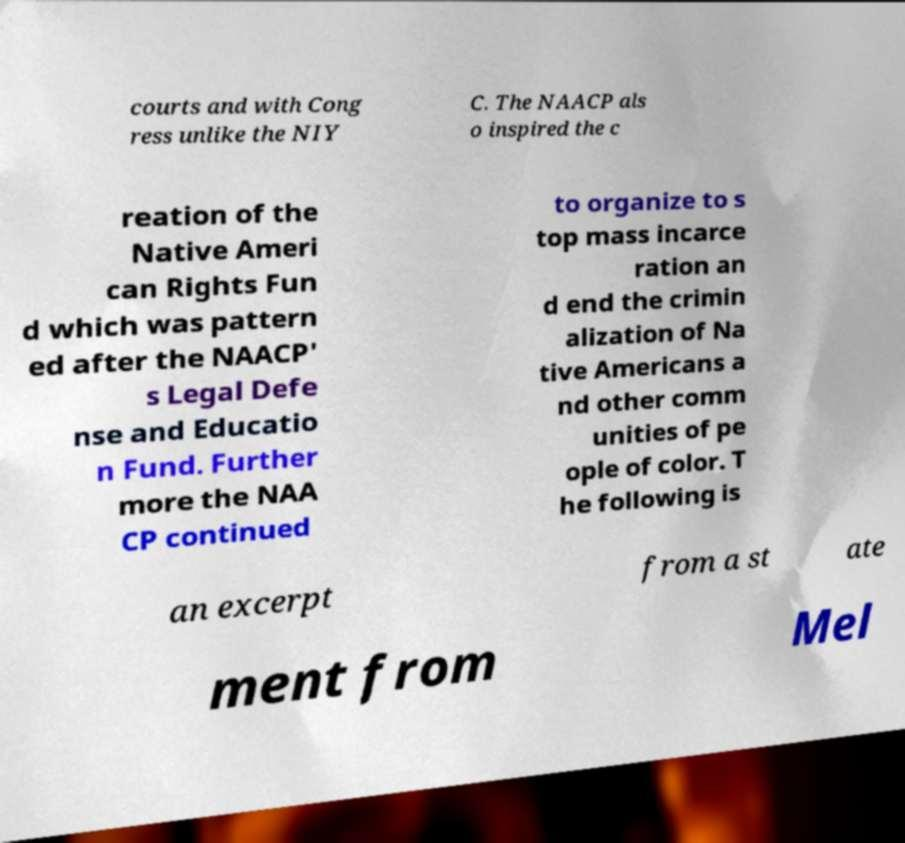Please read and relay the text visible in this image. What does it say? courts and with Cong ress unlike the NIY C. The NAACP als o inspired the c reation of the Native Ameri can Rights Fun d which was pattern ed after the NAACP' s Legal Defe nse and Educatio n Fund. Further more the NAA CP continued to organize to s top mass incarce ration an d end the crimin alization of Na tive Americans a nd other comm unities of pe ople of color. T he following is an excerpt from a st ate ment from Mel 